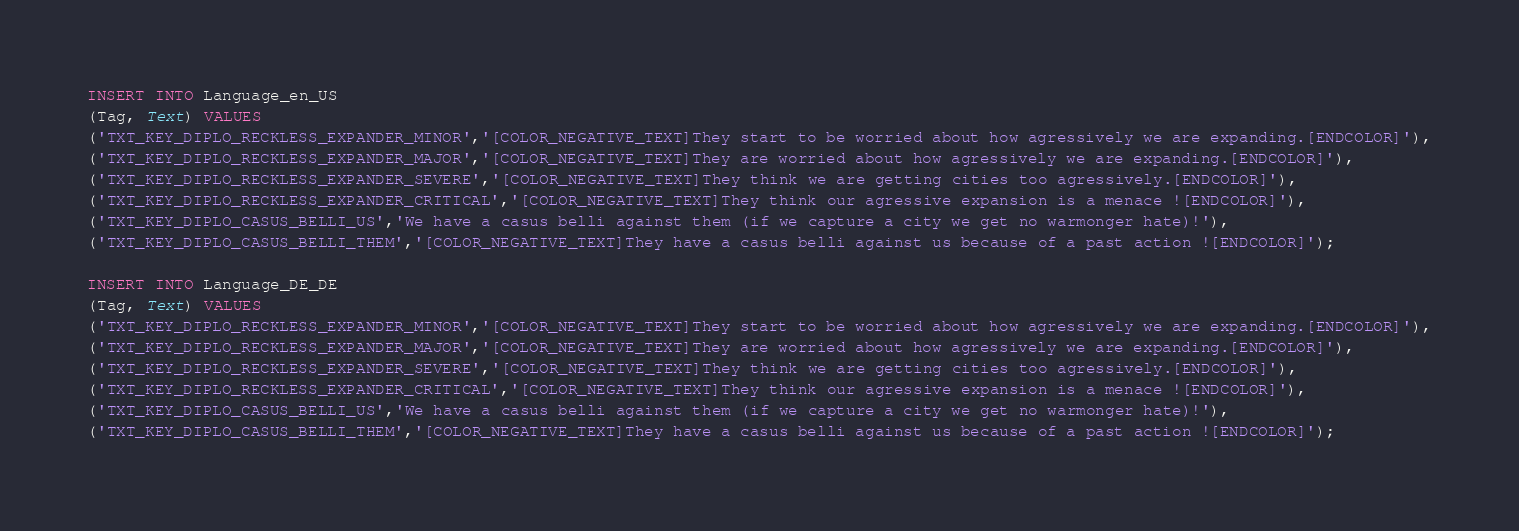<code> <loc_0><loc_0><loc_500><loc_500><_SQL_>INSERT INTO Language_en_US
(Tag, Text) VALUES
('TXT_KEY_DIPLO_RECKLESS_EXPANDER_MINOR','[COLOR_NEGATIVE_TEXT]They start to be worried about how agressively we are expanding.[ENDCOLOR]'),
('TXT_KEY_DIPLO_RECKLESS_EXPANDER_MAJOR','[COLOR_NEGATIVE_TEXT]They are worried about how agressively we are expanding.[ENDCOLOR]'),
('TXT_KEY_DIPLO_RECKLESS_EXPANDER_SEVERE','[COLOR_NEGATIVE_TEXT]They think we are getting cities too agressively.[ENDCOLOR]'),
('TXT_KEY_DIPLO_RECKLESS_EXPANDER_CRITICAL','[COLOR_NEGATIVE_TEXT]They think our agressive expansion is a menace ![ENDCOLOR]'),
('TXT_KEY_DIPLO_CASUS_BELLI_US','We have a casus belli against them (if we capture a city we get no warmonger hate)!'),
('TXT_KEY_DIPLO_CASUS_BELLI_THEM','[COLOR_NEGATIVE_TEXT]They have a casus belli against us because of a past action ![ENDCOLOR]');

INSERT INTO Language_DE_DE
(Tag, Text) VALUES
('TXT_KEY_DIPLO_RECKLESS_EXPANDER_MINOR','[COLOR_NEGATIVE_TEXT]They start to be worried about how agressively we are expanding.[ENDCOLOR]'),
('TXT_KEY_DIPLO_RECKLESS_EXPANDER_MAJOR','[COLOR_NEGATIVE_TEXT]They are worried about how agressively we are expanding.[ENDCOLOR]'),
('TXT_KEY_DIPLO_RECKLESS_EXPANDER_SEVERE','[COLOR_NEGATIVE_TEXT]They think we are getting cities too agressively.[ENDCOLOR]'),
('TXT_KEY_DIPLO_RECKLESS_EXPANDER_CRITICAL','[COLOR_NEGATIVE_TEXT]They think our agressive expansion is a menace ![ENDCOLOR]'),
('TXT_KEY_DIPLO_CASUS_BELLI_US','We have a casus belli against them (if we capture a city we get no warmonger hate)!'),
('TXT_KEY_DIPLO_CASUS_BELLI_THEM','[COLOR_NEGATIVE_TEXT]They have a casus belli against us because of a past action ![ENDCOLOR]');
</code> 